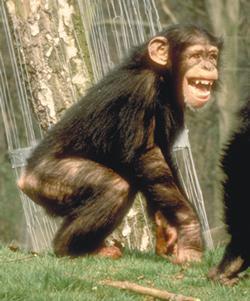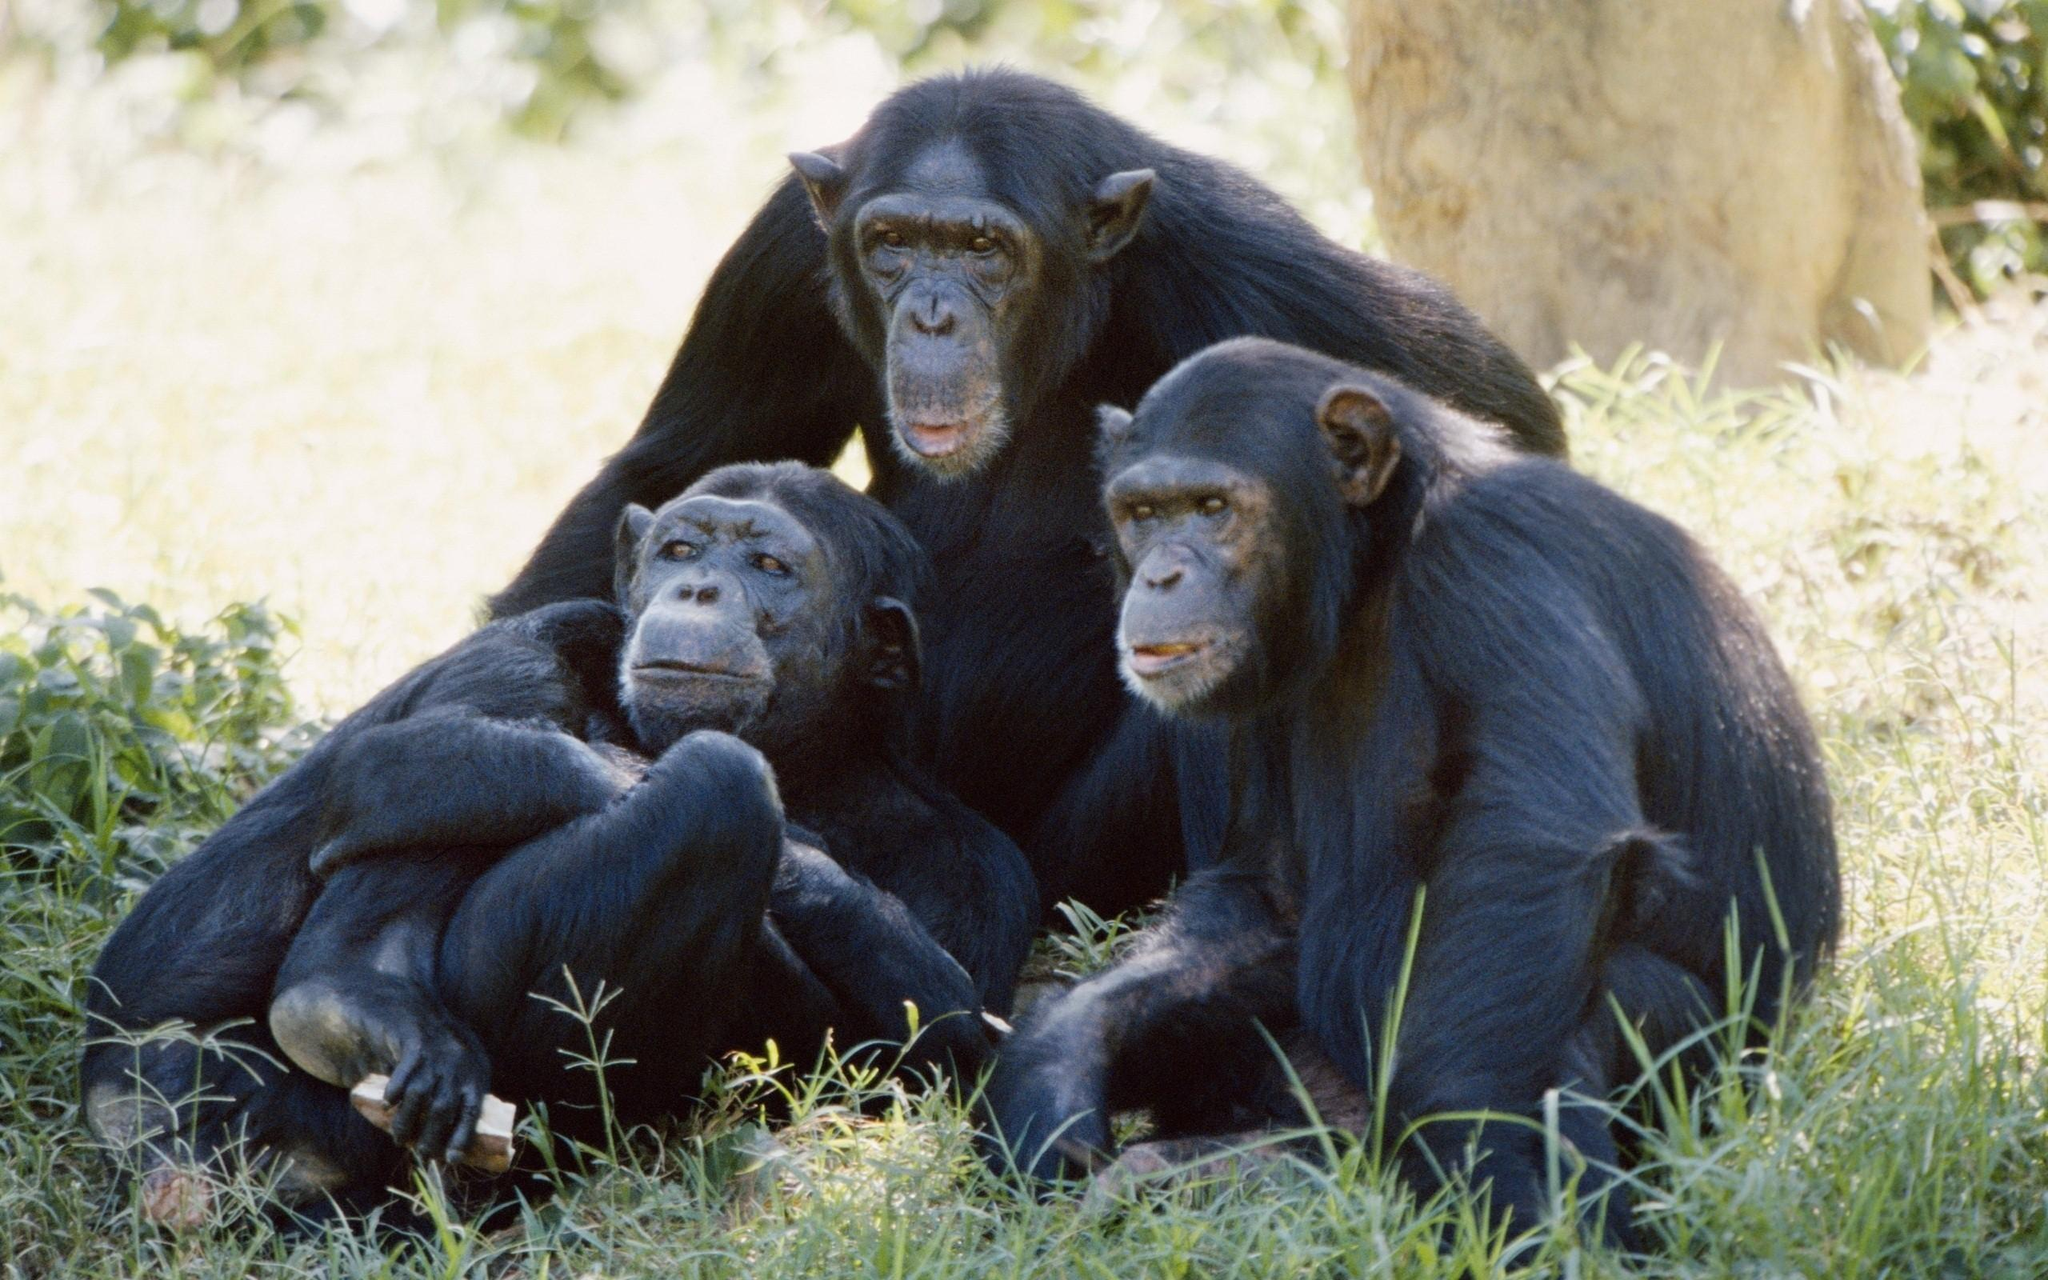The first image is the image on the left, the second image is the image on the right. For the images shown, is this caption "One image has a single monkey who has his mouth open, with a visible tree in the background and green grass." true? Answer yes or no. Yes. The first image is the image on the left, the second image is the image on the right. Given the left and right images, does the statement "An image with more than one ape shows the bulbous pinkish rear of one ape." hold true? Answer yes or no. No. 